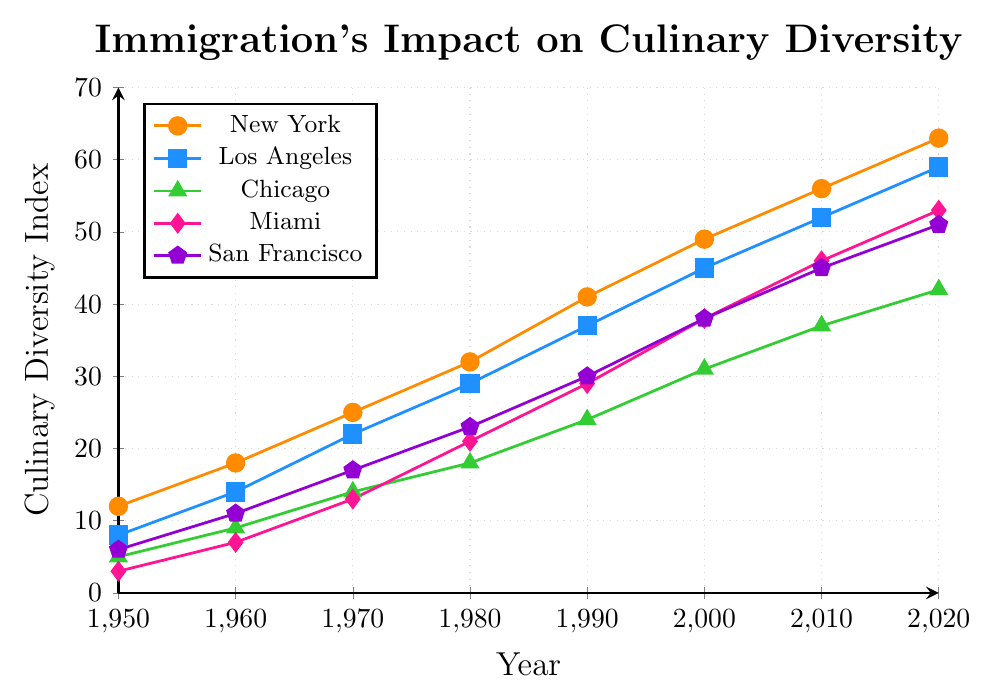What is the trend in culinary diversity for New York from 1950 to 2020? The culinary diversity index for New York increases steadily from 12 in 1950 to 63 in 2020. This indicates a positive and consistent growth trend over the years.
Answer: Positive trend In which year did Los Angeles surpass a Culinary Diversity Index of 30? The data shows Los Angeles exceeded a Culinary Diversity Index of 30 between 1980 (29) and 1990 (37), so it occurred in the year 1990.
Answer: 1990 Which city had the highest culinary diversity index in the year 2000? Checking the values for the year 2000, New York (49), Los Angeles (45), Chicago (31), Miami (38), and San Francisco (38). New York has the highest index of 49.
Answer: New York What is the difference in the culinary diversity index between Miami and Chicago in 2020? In 2020, Miami has an index of 53 and Chicago has an index of 42. The difference is 53 - 42.
Answer: 11 Which city showed the greatest increase in culinary diversity index from 1950 to 2020? By looking at the data: New York increased from 12 to 63 (+51), Los Angeles from 8 to 59 (+51), Chicago from 5 to 42 (+37), Miami from 3 to 53 (+50), and San Francisco from 6 to 51 (+45). Both New York and Los Angeles showed the greatest increase of +51.
Answer: New York and Los Angeles Calculate the average culinary diversity index of San Francisco for the decades listed. Sum of San Francisco's indices: 6 + 11 + 17 + 23 + 30 + 38 + 45 + 51 = 221. Number of decades listed: 8. Average is 221/8.
Answer: 27.625 Is there any city where the culinary diversity index follows a linear trend? A linear trend in the visual would be a straight line. All cities exhibit a generally steady positive slope, suggesting a somewhat linear trend; however, New York and Los Angeles follow an almost perfect straight-line trend from 1950 to 2020.
Answer: Yes, New York and Los Angeles Based on the visual data, which city had the smallest culinary diversity index in 1950? Looking at the initial values in 1950: New York (12), Los Angeles (8), Chicago (5), Miami (3), San Francisco (6). Miami has the smallest value of 3.
Answer: Miami 